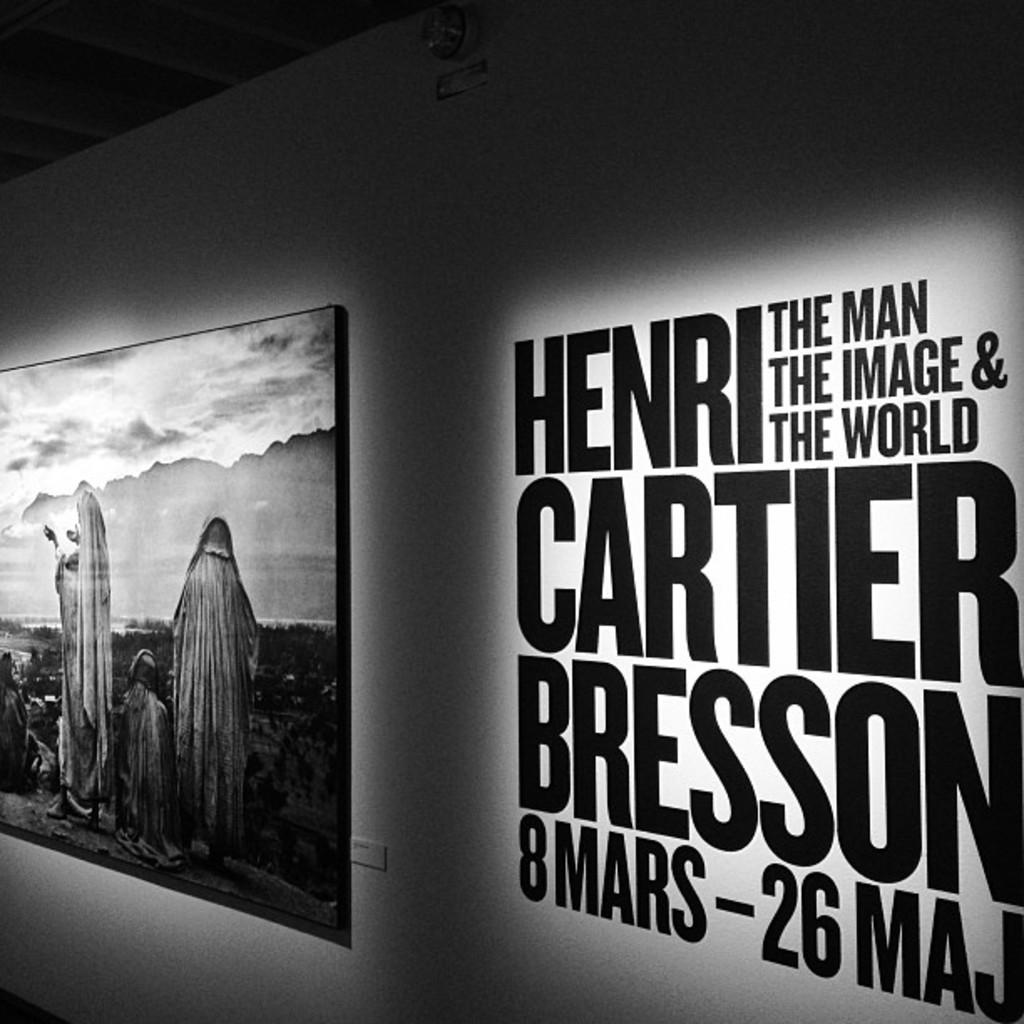Provide a one-sentence caption for the provided image. An art exhibit by the famous Henri Cartier Bresson is being displayed. 